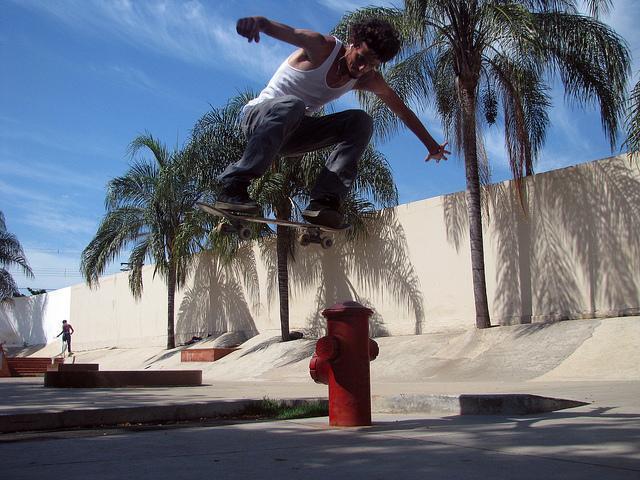How many benches are there?
Give a very brief answer. 1. 